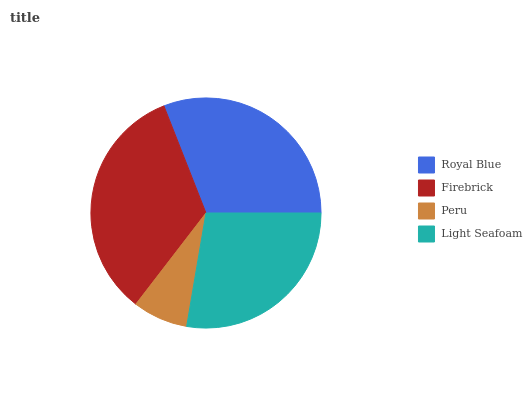Is Peru the minimum?
Answer yes or no. Yes. Is Firebrick the maximum?
Answer yes or no. Yes. Is Firebrick the minimum?
Answer yes or no. No. Is Peru the maximum?
Answer yes or no. No. Is Firebrick greater than Peru?
Answer yes or no. Yes. Is Peru less than Firebrick?
Answer yes or no. Yes. Is Peru greater than Firebrick?
Answer yes or no. No. Is Firebrick less than Peru?
Answer yes or no. No. Is Royal Blue the high median?
Answer yes or no. Yes. Is Light Seafoam the low median?
Answer yes or no. Yes. Is Light Seafoam the high median?
Answer yes or no. No. Is Peru the low median?
Answer yes or no. No. 